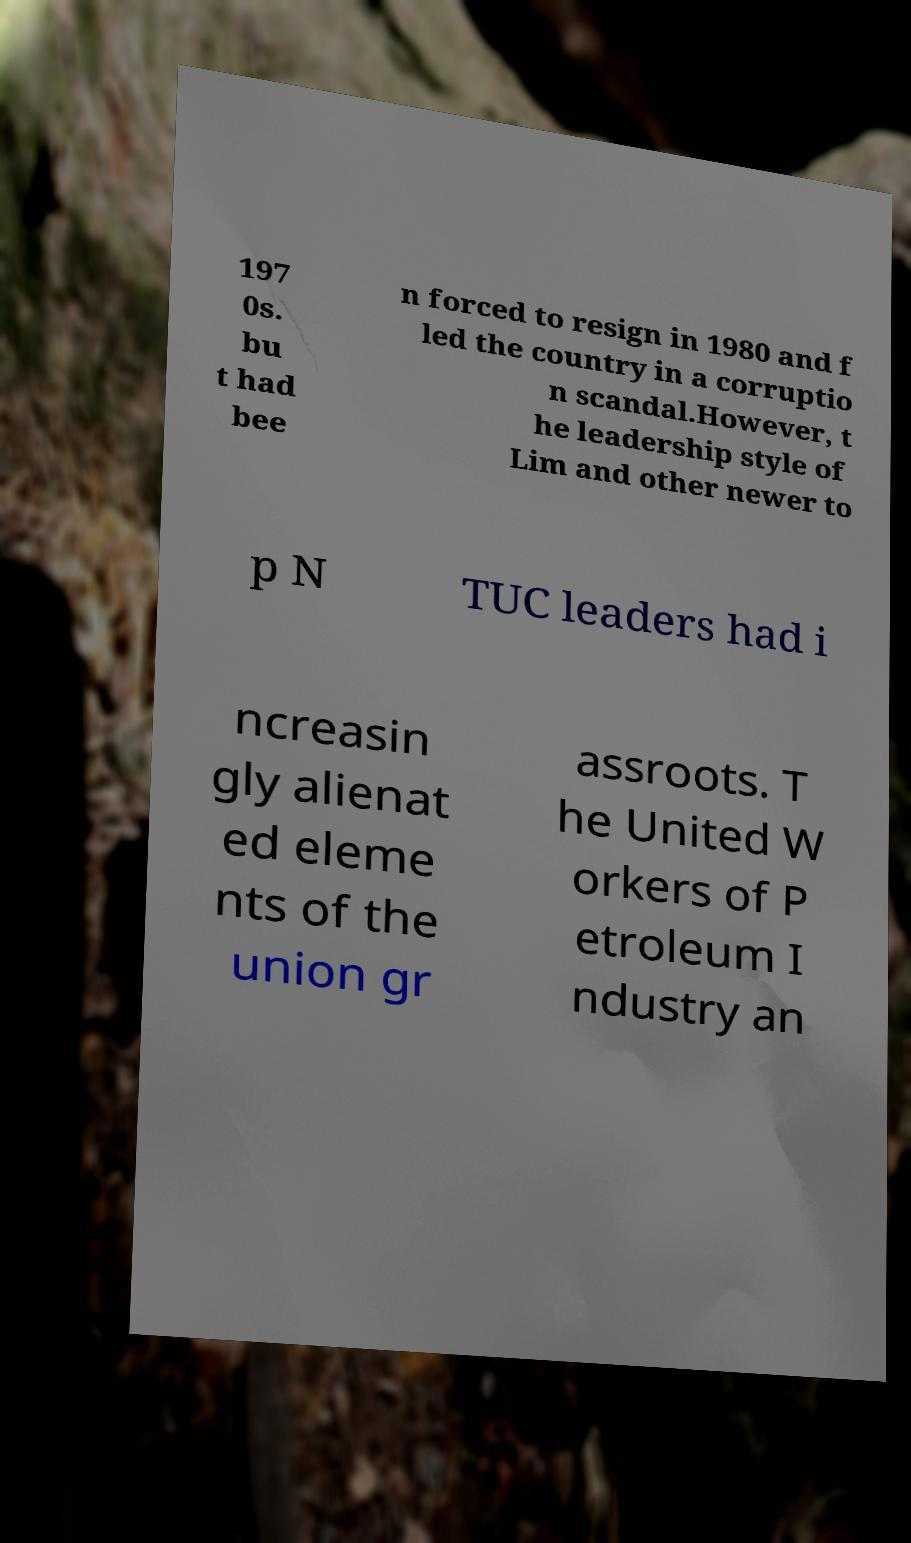What messages or text are displayed in this image? I need them in a readable, typed format. 197 0s. bu t had bee n forced to resign in 1980 and f led the country in a corruptio n scandal.However, t he leadership style of Lim and other newer to p N TUC leaders had i ncreasin gly alienat ed eleme nts of the union gr assroots. T he United W orkers of P etroleum I ndustry an 